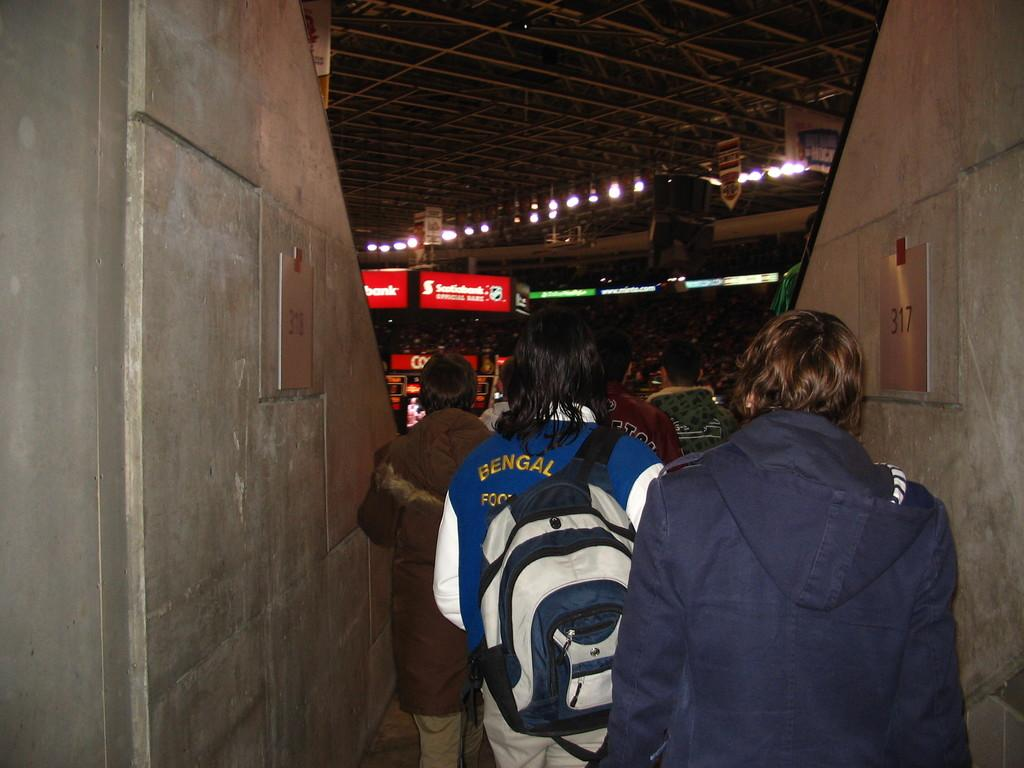What is the main subject of the image? The main subject of the image is a group of boys. What are the boys doing in the image? The boys are moving in a stadium. What can be seen in the front of the image? There is a red banner located in the front of the image. What type of structure is visible in the front bottom side of the image? There are two concrete walls visible in the front bottom side of the image. What type of attraction is the boys visiting in the image? There is no specific attraction mentioned or visible in the image; it only shows a group of boys moving in a stadium. 